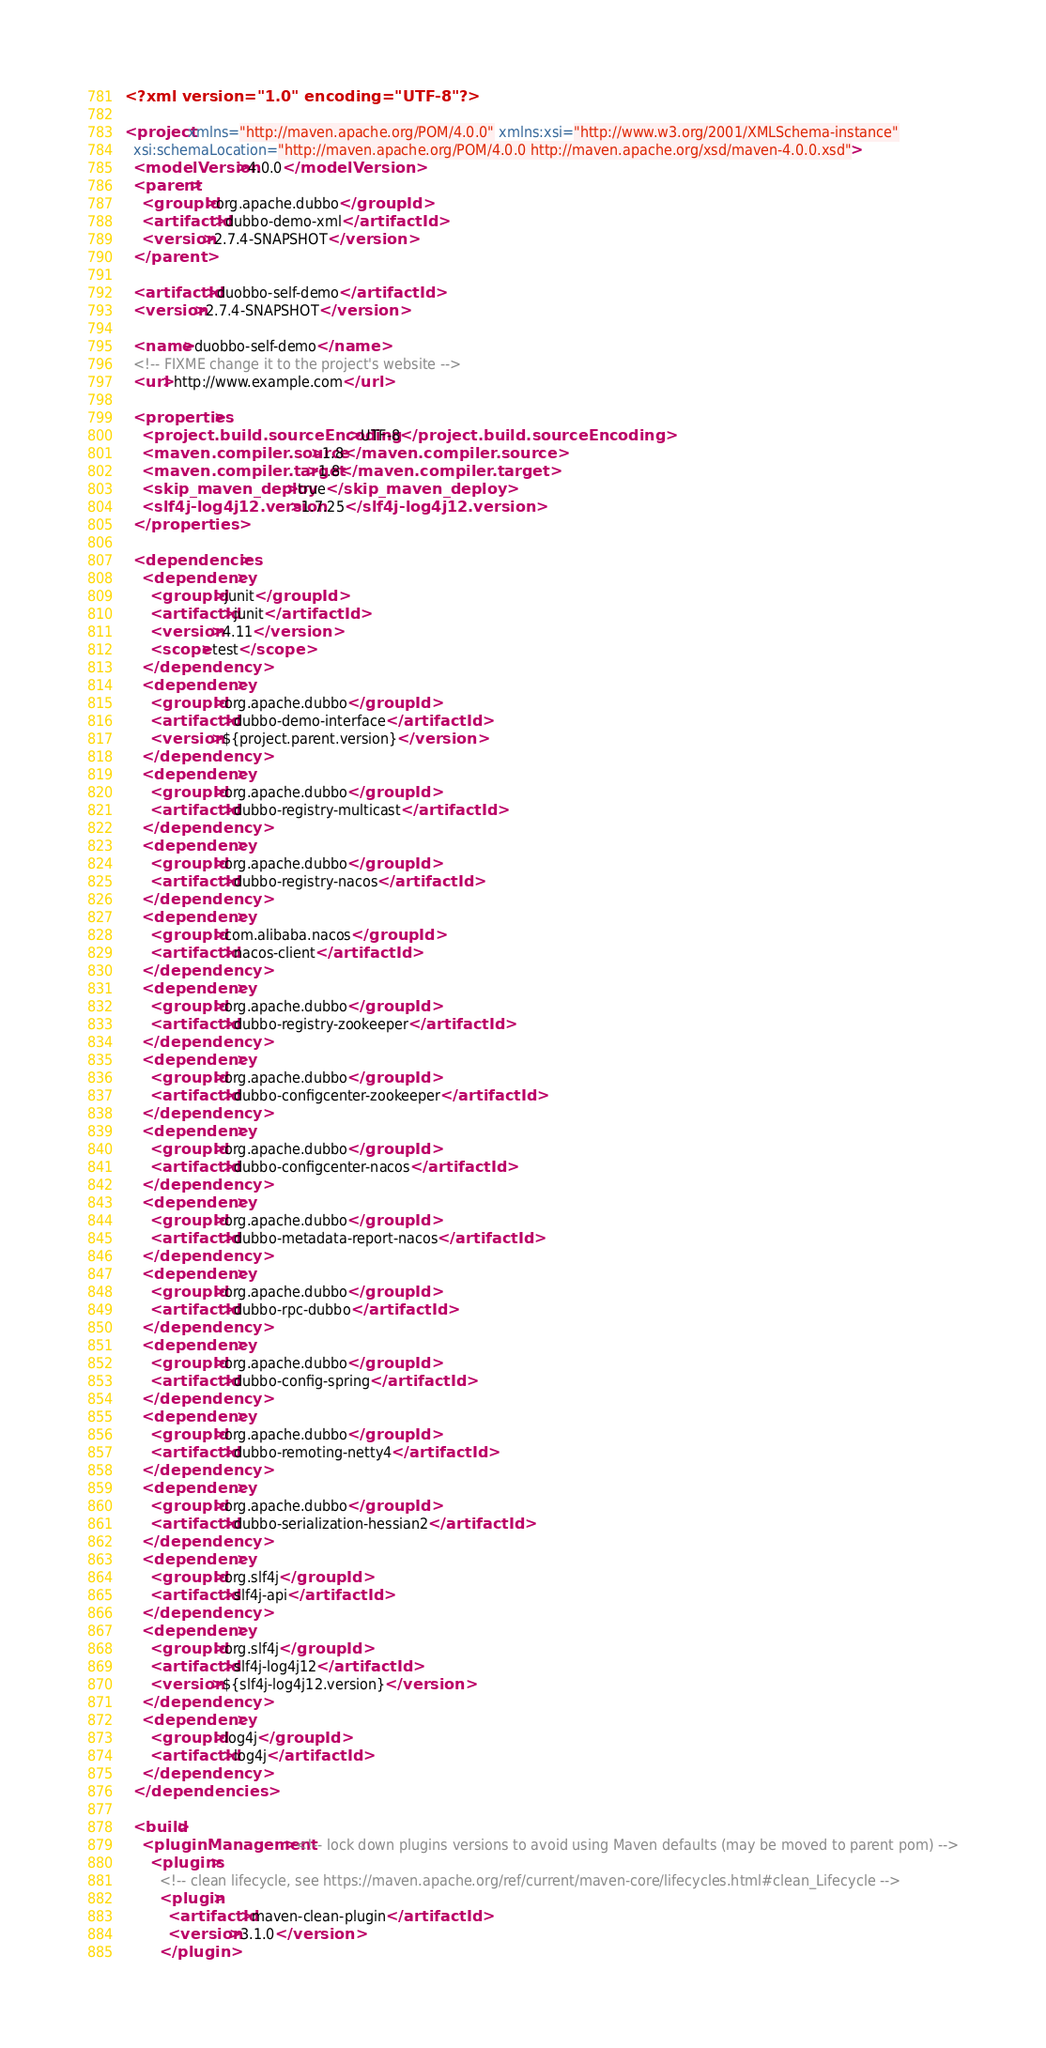Convert code to text. <code><loc_0><loc_0><loc_500><loc_500><_XML_><?xml version="1.0" encoding="UTF-8"?>

<project xmlns="http://maven.apache.org/POM/4.0.0" xmlns:xsi="http://www.w3.org/2001/XMLSchema-instance"
  xsi:schemaLocation="http://maven.apache.org/POM/4.0.0 http://maven.apache.org/xsd/maven-4.0.0.xsd">
  <modelVersion>4.0.0</modelVersion>
  <parent>
    <groupId>org.apache.dubbo</groupId>
    <artifactId>dubbo-demo-xml</artifactId>
    <version>2.7.4-SNAPSHOT</version>
  </parent>

  <artifactId>duobbo-self-demo</artifactId>
  <version>2.7.4-SNAPSHOT</version>

  <name>duobbo-self-demo</name>
  <!-- FIXME change it to the project's website -->
  <url>http://www.example.com</url>

  <properties>
    <project.build.sourceEncoding>UTF-8</project.build.sourceEncoding>
    <maven.compiler.source>1.8</maven.compiler.source>
    <maven.compiler.target>1.8</maven.compiler.target>
    <skip_maven_deploy>true</skip_maven_deploy>
    <slf4j-log4j12.version>1.7.25</slf4j-log4j12.version>
  </properties>

  <dependencies>
    <dependency>
      <groupId>junit</groupId>
      <artifactId>junit</artifactId>
      <version>4.11</version>
      <scope>test</scope>
    </dependency>
    <dependency>
      <groupId>org.apache.dubbo</groupId>
      <artifactId>dubbo-demo-interface</artifactId>
      <version>${project.parent.version}</version>
    </dependency>
    <dependency>
      <groupId>org.apache.dubbo</groupId>
      <artifactId>dubbo-registry-multicast</artifactId>
    </dependency>
    <dependency>
      <groupId>org.apache.dubbo</groupId>
      <artifactId>dubbo-registry-nacos</artifactId>
    </dependency>
    <dependency>
      <groupId>com.alibaba.nacos</groupId>
      <artifactId>nacos-client</artifactId>
    </dependency>
    <dependency>
      <groupId>org.apache.dubbo</groupId>
      <artifactId>dubbo-registry-zookeeper</artifactId>
    </dependency>
    <dependency>
      <groupId>org.apache.dubbo</groupId>
      <artifactId>dubbo-configcenter-zookeeper</artifactId>
    </dependency>
    <dependency>
      <groupId>org.apache.dubbo</groupId>
      <artifactId>dubbo-configcenter-nacos</artifactId>
    </dependency>
    <dependency>
      <groupId>org.apache.dubbo</groupId>
      <artifactId>dubbo-metadata-report-nacos</artifactId>
    </dependency>
    <dependency>
      <groupId>org.apache.dubbo</groupId>
      <artifactId>dubbo-rpc-dubbo</artifactId>
    </dependency>
    <dependency>
      <groupId>org.apache.dubbo</groupId>
      <artifactId>dubbo-config-spring</artifactId>
    </dependency>
    <dependency>
      <groupId>org.apache.dubbo</groupId>
      <artifactId>dubbo-remoting-netty4</artifactId>
    </dependency>
    <dependency>
      <groupId>org.apache.dubbo</groupId>
      <artifactId>dubbo-serialization-hessian2</artifactId>
    </dependency>
    <dependency>
      <groupId>org.slf4j</groupId>
      <artifactId>slf4j-api</artifactId>
    </dependency>
    <dependency>
      <groupId>org.slf4j</groupId>
      <artifactId>slf4j-log4j12</artifactId>
      <version>${slf4j-log4j12.version}</version>
    </dependency>
    <dependency>
      <groupId>log4j</groupId>
      <artifactId>log4j</artifactId>
    </dependency>
  </dependencies>

  <build>
    <pluginManagement><!-- lock down plugins versions to avoid using Maven defaults (may be moved to parent pom) -->
      <plugins>
        <!-- clean lifecycle, see https://maven.apache.org/ref/current/maven-core/lifecycles.html#clean_Lifecycle -->
        <plugin>
          <artifactId>maven-clean-plugin</artifactId>
          <version>3.1.0</version>
        </plugin></code> 